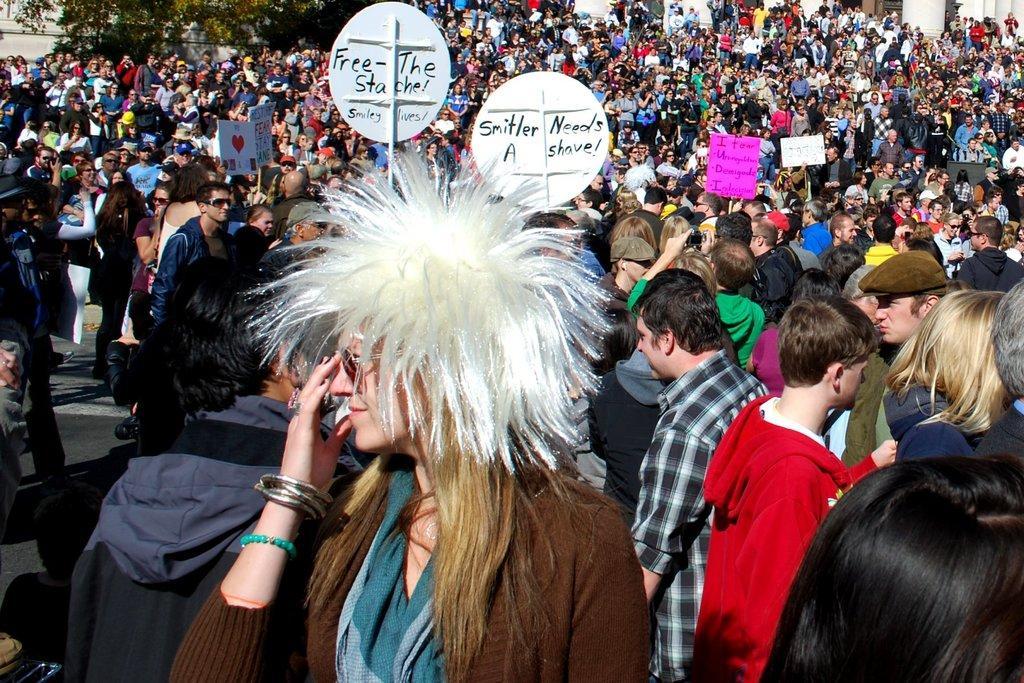Please provide a concise description of this image. In this image I can see a huge crowd of people among which a few people are holding boards in their hands with some text. 